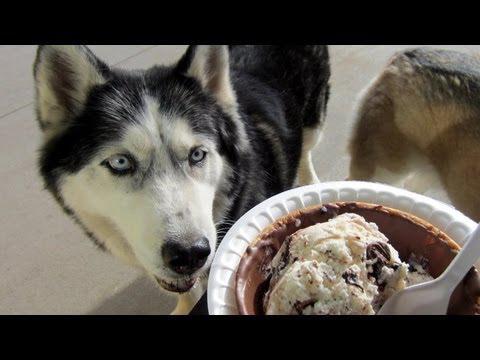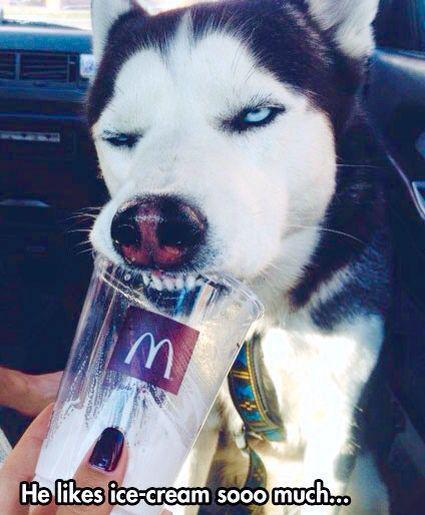The first image is the image on the left, the second image is the image on the right. Evaluate the accuracy of this statement regarding the images: "One of the treats is on a popsicle stick.". Is it true? Answer yes or no. No. 